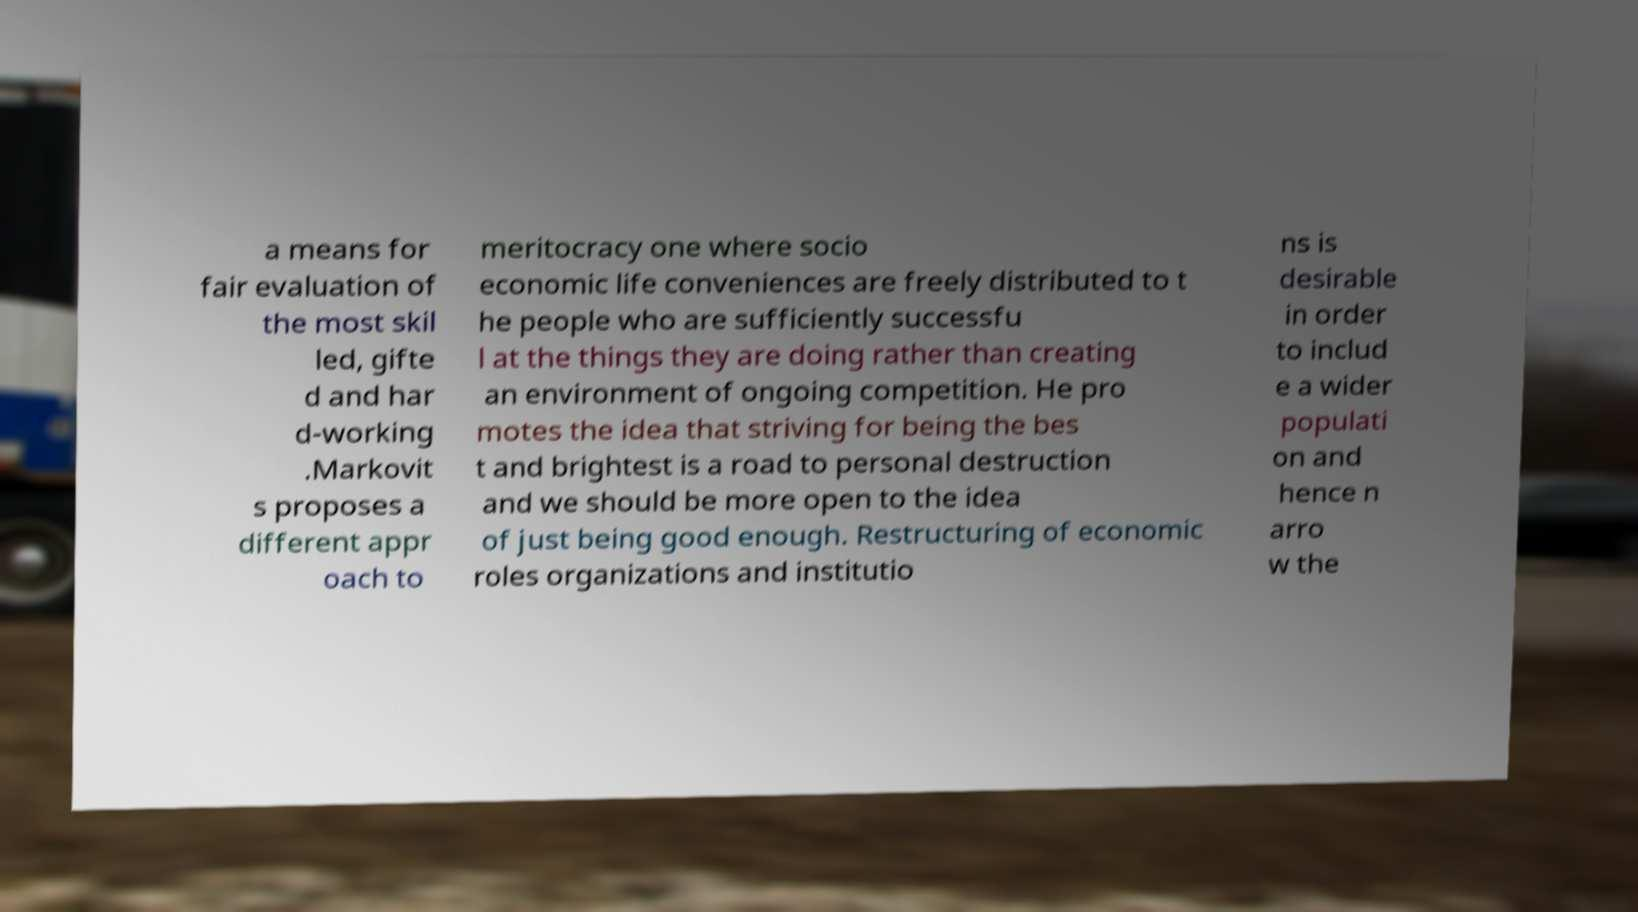There's text embedded in this image that I need extracted. Can you transcribe it verbatim? a means for fair evaluation of the most skil led, gifte d and har d-working .Markovit s proposes a different appr oach to meritocracy one where socio economic life conveniences are freely distributed to t he people who are sufficiently successfu l at the things they are doing rather than creating an environment of ongoing competition. He pro motes the idea that striving for being the bes t and brightest is a road to personal destruction and we should be more open to the idea of just being good enough. Restructuring of economic roles organizations and institutio ns is desirable in order to includ e a wider populati on and hence n arro w the 